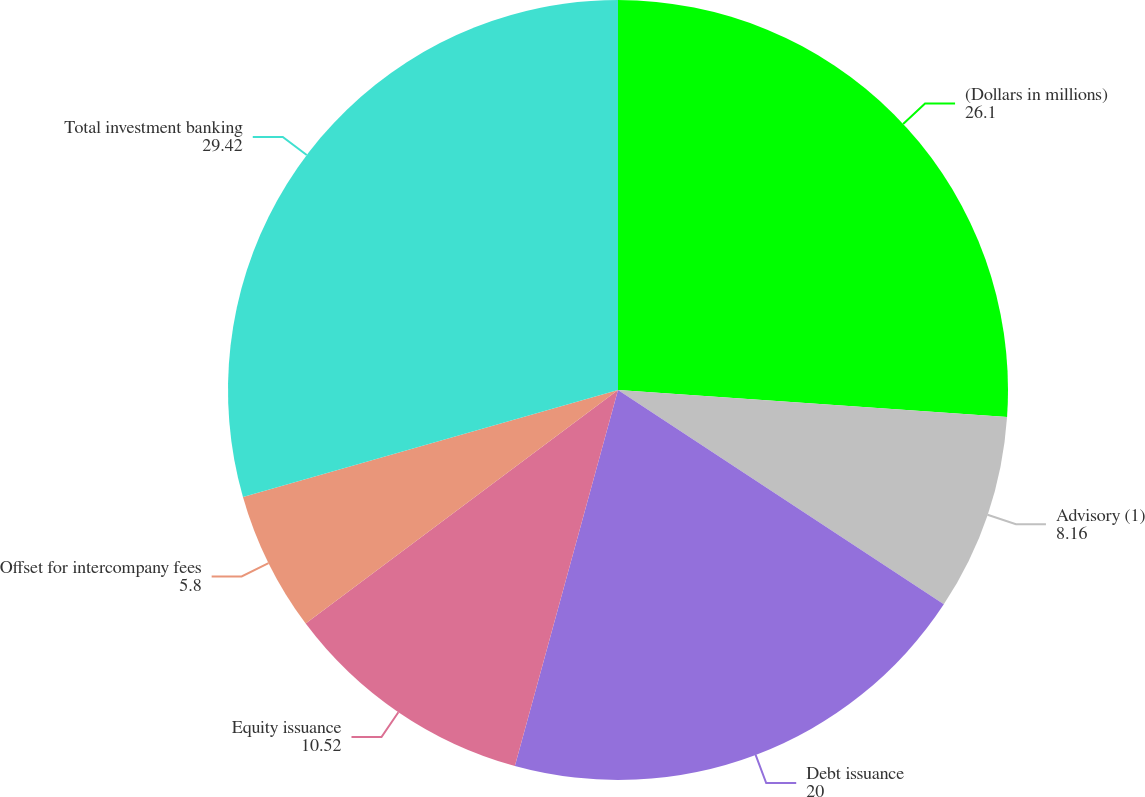Convert chart. <chart><loc_0><loc_0><loc_500><loc_500><pie_chart><fcel>(Dollars in millions)<fcel>Advisory (1)<fcel>Debt issuance<fcel>Equity issuance<fcel>Offset for intercompany fees<fcel>Total investment banking<nl><fcel>26.1%<fcel>8.16%<fcel>20.0%<fcel>10.52%<fcel>5.8%<fcel>29.42%<nl></chart> 